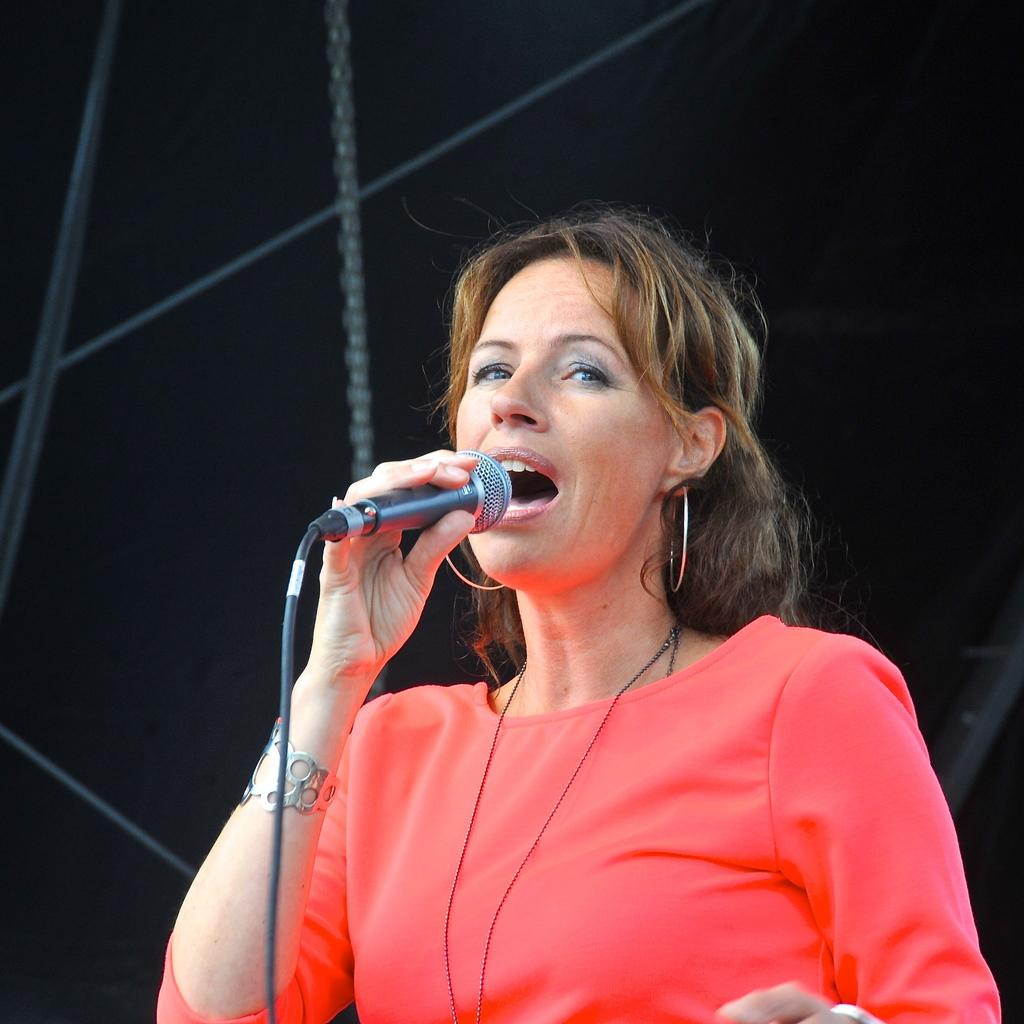What is the main subject of the image? The main subject of the image is a woman. What is the woman holding in the image? The woman is holding a microphone. What type of bird can be seen perched on the woman's shoulder in the image? There is no bird present in the image; the woman is holding a microphone. What type of fruit is the woman holding in her other hand in the image? The woman is not holding any fruit in the image; she is only holding a microphone. 